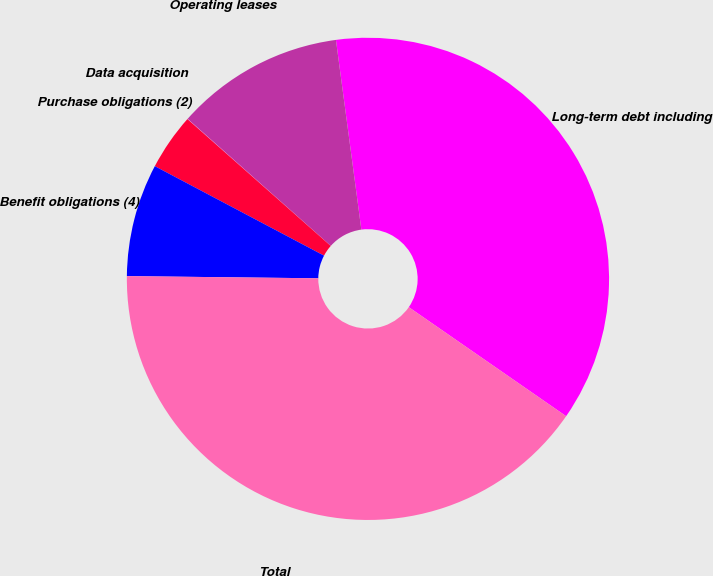<chart> <loc_0><loc_0><loc_500><loc_500><pie_chart><fcel>Long-term debt including<fcel>Operating leases<fcel>Data acquisition<fcel>Purchase obligations (2)<fcel>Benefit obligations (4)<fcel>Total<nl><fcel>36.77%<fcel>11.33%<fcel>0.02%<fcel>3.79%<fcel>7.56%<fcel>40.54%<nl></chart> 